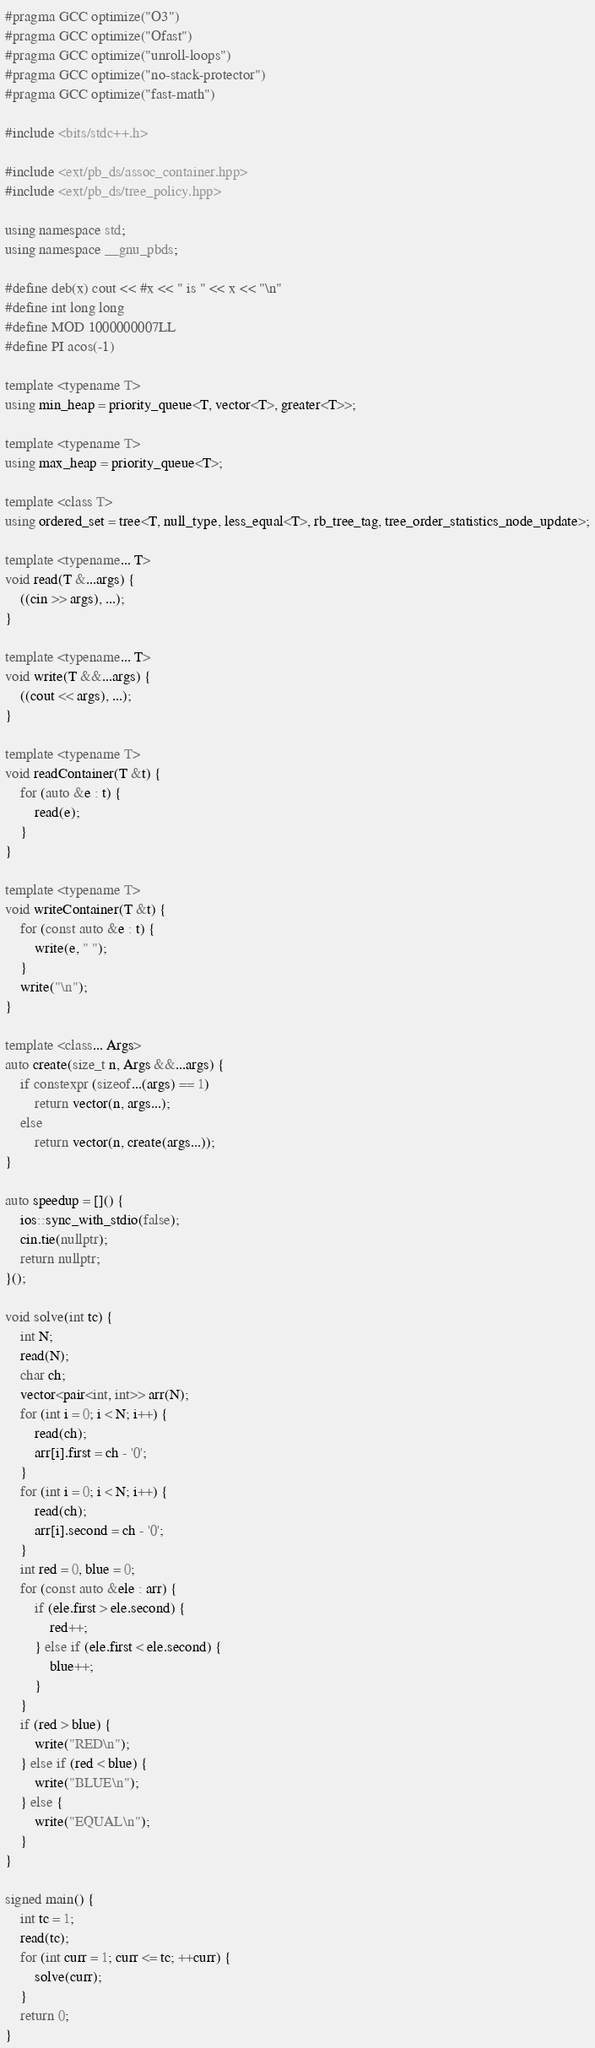Convert code to text. <code><loc_0><loc_0><loc_500><loc_500><_C++_>#pragma GCC optimize("O3")
#pragma GCC optimize("Ofast")
#pragma GCC optimize("unroll-loops")
#pragma GCC optimize("no-stack-protector")
#pragma GCC optimize("fast-math")

#include <bits/stdc++.h>

#include <ext/pb_ds/assoc_container.hpp>
#include <ext/pb_ds/tree_policy.hpp>

using namespace std;
using namespace __gnu_pbds;

#define deb(x) cout << #x << " is " << x << "\n"
#define int long long
#define MOD 1000000007LL
#define PI acos(-1)

template <typename T>
using min_heap = priority_queue<T, vector<T>, greater<T>>;

template <typename T>
using max_heap = priority_queue<T>;

template <class T>
using ordered_set = tree<T, null_type, less_equal<T>, rb_tree_tag, tree_order_statistics_node_update>;

template <typename... T>
void read(T &...args) {
    ((cin >> args), ...);
}

template <typename... T>
void write(T &&...args) {
    ((cout << args), ...);
}

template <typename T>
void readContainer(T &t) {
    for (auto &e : t) {
        read(e);
    }
}

template <typename T>
void writeContainer(T &t) {
    for (const auto &e : t) {
        write(e, " ");
    }
    write("\n");
}

template <class... Args>
auto create(size_t n, Args &&...args) {
    if constexpr (sizeof...(args) == 1)
        return vector(n, args...);
    else
        return vector(n, create(args...));
}

auto speedup = []() {
    ios::sync_with_stdio(false);
    cin.tie(nullptr);
    return nullptr;
}();

void solve(int tc) {
    int N;
    read(N);
    char ch;
    vector<pair<int, int>> arr(N);
    for (int i = 0; i < N; i++) {
        read(ch);
        arr[i].first = ch - '0';
    }
    for (int i = 0; i < N; i++) {
        read(ch);
        arr[i].second = ch - '0';
    }
    int red = 0, blue = 0;
    for (const auto &ele : arr) {
        if (ele.first > ele.second) {
            red++;
        } else if (ele.first < ele.second) {
            blue++;
        }
    }
    if (red > blue) {
        write("RED\n");
    } else if (red < blue) {
        write("BLUE\n");
    } else {
        write("EQUAL\n");
    }
}

signed main() {
    int tc = 1;
    read(tc);
    for (int curr = 1; curr <= tc; ++curr) {
        solve(curr);
    }
    return 0;
}</code> 